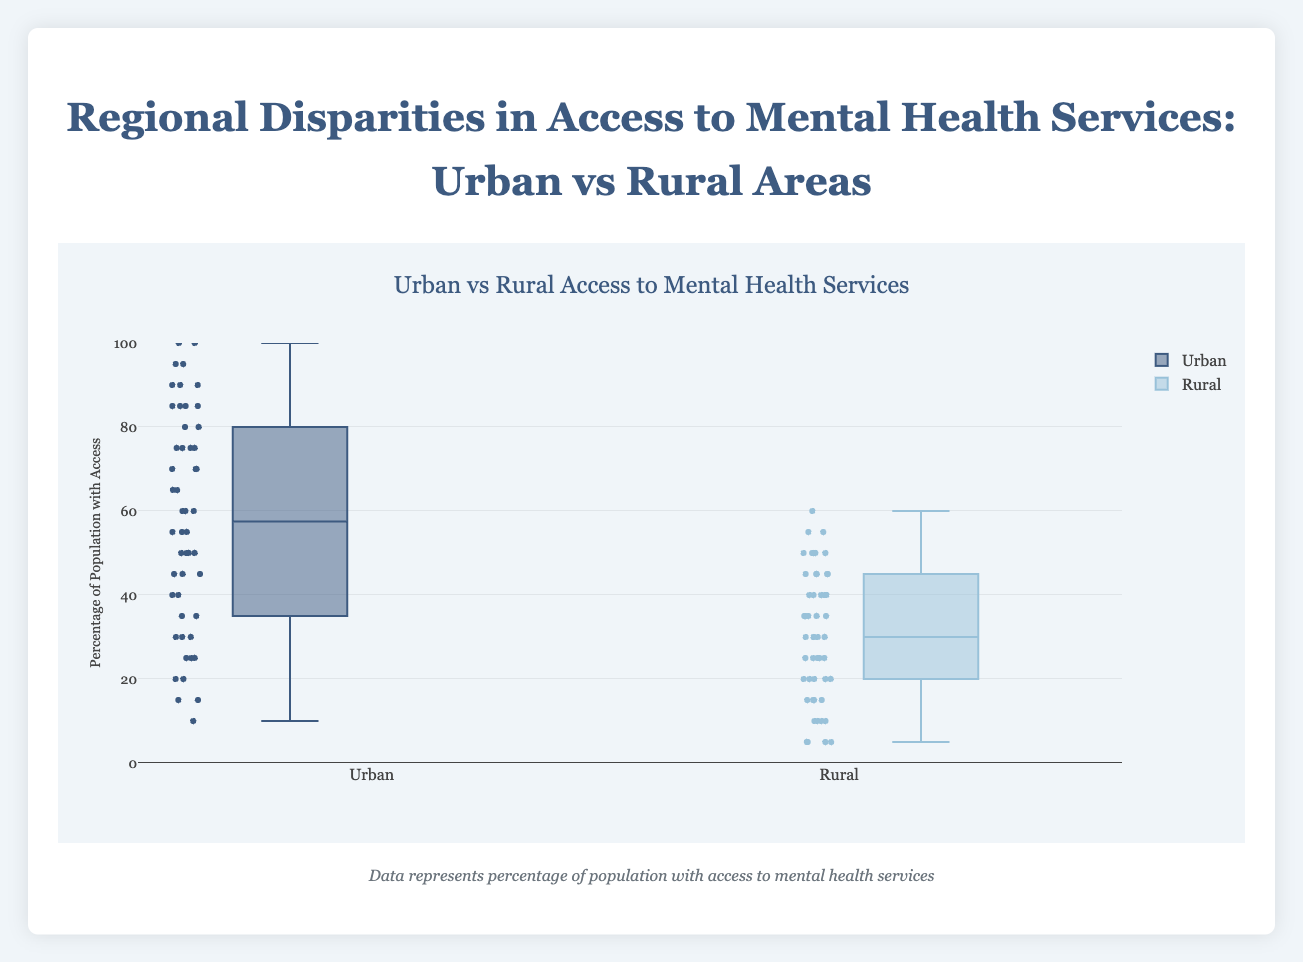what is the title of the plot? The title of the plot is displayed at the top, centered, with a larger font size. It reads "Urban vs Rural Access to Mental Health Services".
Answer: Urban vs Rural Access to Mental Health Services What are the two categories compared in the box plot? The box plot has two distinct sets of data represented: one for "Urban" and the other for "Rural". These categories label the two box plot groups.
Answer: Urban and Rural Which category tends to have a higher overall percentage access to mental health services? The boxes for "Urban" data are generally positioned higher on the y-axis compared to those for "Rural", indicating higher overall access percentages. Observing the median lines, the urban category shows substantially higher values.
Answer: Urban What is the approximate median percentage for urban areas? The median is the line inside the box. For urban areas, this line seems to be somewhere around the middle upper range, roughly at 60%.
Answer: 60% How does the median access percentage in rural areas compare to urban areas? The median access line for rural areas is much lower compared to that of urban areas. Specifically, the median for rural is about 27.5%, while for urban it's about 60%.
Answer: Much lower What is the range of access percentages for rural areas? The range of access is the difference between the maximum and minimum values. For rural areas, this extends from around 5% to around 60%.
Answer: 5% to 60% Which category has the wider interquartile range (IQR) and what does this signify? The interquartile range (IQR) is the distance between the first quartile (Q1) and the third quartile (Q3). Observing the plot, the urban IQR seems wider than the rural IQR indicating more variability in urban access to mental health services.
Answer: Urban Are there any outliers in the data for either category and what do they indicate? Outliers are typically points that lie outside the whiskers of the box plot. For both urban and rural categories, there seems to be no significant outliers represented, indicating consistent data without extreme deviations.
Answer: No significant outliers How does the variation in access to mental health services differ between urban and rural areas? Variation is observed by looking at the spread and the IQR. Urban areas exhibit both a higher median and a broader range compared to rural areas, which suggests greater consistency and access in urban settings but also a wider disparity among different cities.
Answer: Urban has higher variation What does the color of the boxes signify in the plot? The different colors visually distinguish the urban and rural categories; urban is depicted in a dark blue shade, while rural is in a lighter blue. These color differences facilitate clear comparison between the groups.
Answer: Differentiate between urban and rural categories 